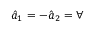<formula> <loc_0><loc_0><loc_500><loc_500>\hat { a } _ { 1 } = - \hat { a } _ { 2 } = \forall</formula> 